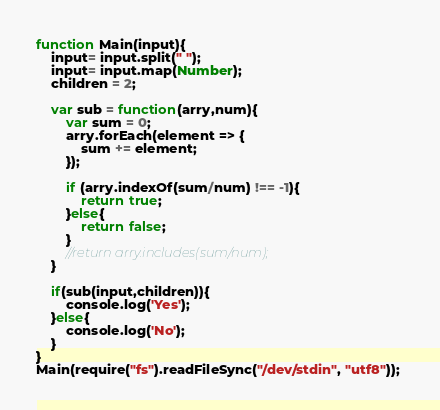Convert code to text. <code><loc_0><loc_0><loc_500><loc_500><_JavaScript_>function Main(input){
    input= input.split(" ");
    input= input.map(Number);
    children = 2;
    
    var sub = function(arry,num){
        var sum = 0;
        arry.forEach(element => {
            sum += element;
        });
        
        if (arry.indexOf(sum/num) !== -1){
            return true;
        }else{
            return false;
        }
        //return arry.includes(sum/num);
    }
    
    if(sub(input,children)){
        console.log('Yes');
    }else{
        console.log('No');
    }
}
Main(require("fs").readFileSync("/dev/stdin", "utf8")); </code> 